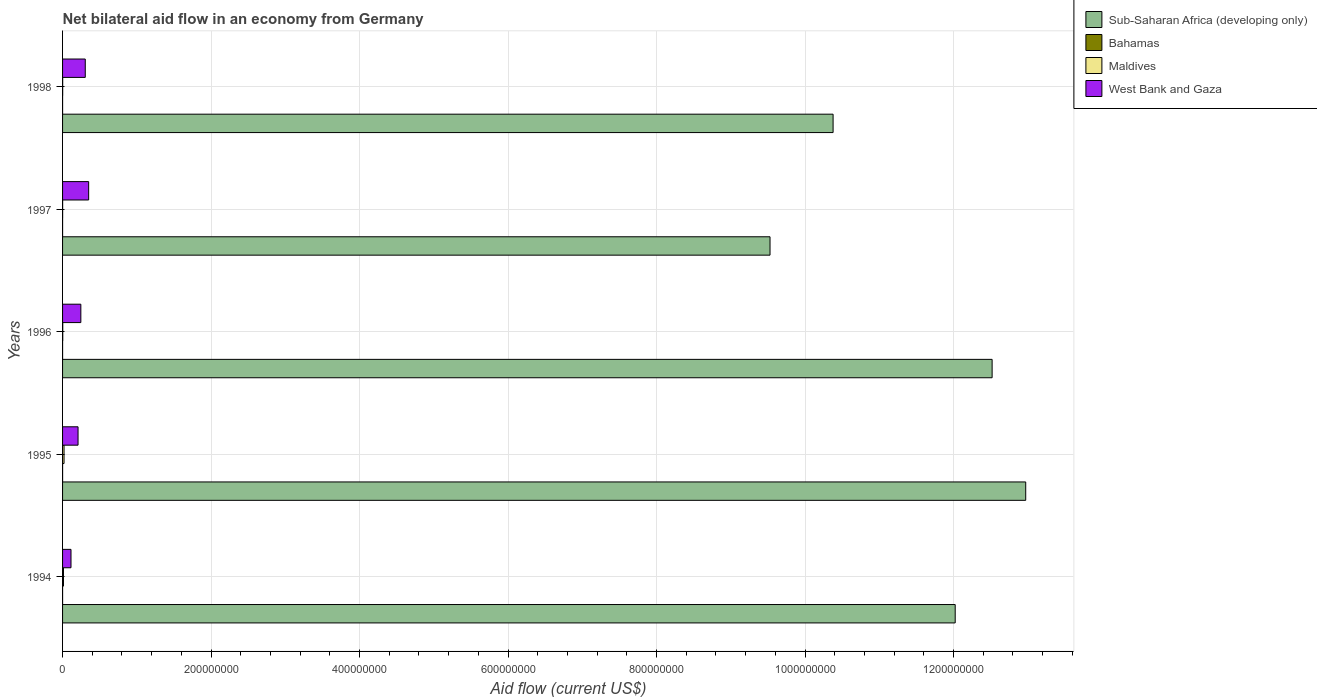How many different coloured bars are there?
Make the answer very short. 4. How many groups of bars are there?
Offer a very short reply. 5. Are the number of bars per tick equal to the number of legend labels?
Provide a succinct answer. Yes. Are the number of bars on each tick of the Y-axis equal?
Make the answer very short. Yes. How many bars are there on the 2nd tick from the top?
Your response must be concise. 4. In how many cases, is the number of bars for a given year not equal to the number of legend labels?
Ensure brevity in your answer.  0. What is the net bilateral aid flow in Bahamas in 1996?
Keep it short and to the point. 2.00e+04. Across all years, what is the maximum net bilateral aid flow in Maldives?
Provide a short and direct response. 1.99e+06. Across all years, what is the minimum net bilateral aid flow in Sub-Saharan Africa (developing only)?
Ensure brevity in your answer.  9.53e+08. In which year was the net bilateral aid flow in West Bank and Gaza maximum?
Your answer should be compact. 1997. In which year was the net bilateral aid flow in Maldives minimum?
Offer a terse response. 1997. What is the total net bilateral aid flow in Maldives in the graph?
Provide a short and direct response. 3.70e+06. What is the difference between the net bilateral aid flow in West Bank and Gaza in 1994 and that in 1996?
Give a very brief answer. -1.32e+07. What is the difference between the net bilateral aid flow in Bahamas in 1994 and the net bilateral aid flow in West Bank and Gaza in 1997?
Your answer should be compact. -3.51e+07. What is the average net bilateral aid flow in Sub-Saharan Africa (developing only) per year?
Provide a succinct answer. 1.15e+09. In the year 1994, what is the difference between the net bilateral aid flow in Bahamas and net bilateral aid flow in West Bank and Gaza?
Provide a short and direct response. -1.14e+07. What is the ratio of the net bilateral aid flow in West Bank and Gaza in 1996 to that in 1998?
Make the answer very short. 0.8. Is the difference between the net bilateral aid flow in Bahamas in 1997 and 1998 greater than the difference between the net bilateral aid flow in West Bank and Gaza in 1997 and 1998?
Provide a succinct answer. No. What is the difference between the highest and the lowest net bilateral aid flow in Sub-Saharan Africa (developing only)?
Keep it short and to the point. 3.44e+08. What does the 2nd bar from the top in 1998 represents?
Ensure brevity in your answer.  Maldives. What does the 2nd bar from the bottom in 1997 represents?
Keep it short and to the point. Bahamas. Is it the case that in every year, the sum of the net bilateral aid flow in Bahamas and net bilateral aid flow in Maldives is greater than the net bilateral aid flow in West Bank and Gaza?
Ensure brevity in your answer.  No. How many bars are there?
Your answer should be compact. 20. Are all the bars in the graph horizontal?
Provide a succinct answer. Yes. What is the difference between two consecutive major ticks on the X-axis?
Offer a very short reply. 2.00e+08. Where does the legend appear in the graph?
Provide a short and direct response. Top right. How many legend labels are there?
Make the answer very short. 4. How are the legend labels stacked?
Give a very brief answer. Vertical. What is the title of the graph?
Keep it short and to the point. Net bilateral aid flow in an economy from Germany. What is the Aid flow (current US$) of Sub-Saharan Africa (developing only) in 1994?
Give a very brief answer. 1.20e+09. What is the Aid flow (current US$) in Maldives in 1994?
Provide a short and direct response. 1.24e+06. What is the Aid flow (current US$) in West Bank and Gaza in 1994?
Make the answer very short. 1.14e+07. What is the Aid flow (current US$) of Sub-Saharan Africa (developing only) in 1995?
Keep it short and to the point. 1.30e+09. What is the Aid flow (current US$) of Maldives in 1995?
Your answer should be compact. 1.99e+06. What is the Aid flow (current US$) in West Bank and Gaza in 1995?
Your answer should be compact. 2.09e+07. What is the Aid flow (current US$) in Sub-Saharan Africa (developing only) in 1996?
Offer a terse response. 1.25e+09. What is the Aid flow (current US$) of West Bank and Gaza in 1996?
Keep it short and to the point. 2.46e+07. What is the Aid flow (current US$) of Sub-Saharan Africa (developing only) in 1997?
Ensure brevity in your answer.  9.53e+08. What is the Aid flow (current US$) in Maldives in 1997?
Offer a very short reply. 7.00e+04. What is the Aid flow (current US$) in West Bank and Gaza in 1997?
Your answer should be very brief. 3.51e+07. What is the Aid flow (current US$) in Sub-Saharan Africa (developing only) in 1998?
Give a very brief answer. 1.04e+09. What is the Aid flow (current US$) in West Bank and Gaza in 1998?
Give a very brief answer. 3.06e+07. Across all years, what is the maximum Aid flow (current US$) in Sub-Saharan Africa (developing only)?
Give a very brief answer. 1.30e+09. Across all years, what is the maximum Aid flow (current US$) of Bahamas?
Provide a short and direct response. 3.00e+04. Across all years, what is the maximum Aid flow (current US$) of Maldives?
Your response must be concise. 1.99e+06. Across all years, what is the maximum Aid flow (current US$) of West Bank and Gaza?
Keep it short and to the point. 3.51e+07. Across all years, what is the minimum Aid flow (current US$) in Sub-Saharan Africa (developing only)?
Ensure brevity in your answer.  9.53e+08. Across all years, what is the minimum Aid flow (current US$) of Bahamas?
Your response must be concise. 10000. Across all years, what is the minimum Aid flow (current US$) of West Bank and Gaza?
Provide a short and direct response. 1.14e+07. What is the total Aid flow (current US$) of Sub-Saharan Africa (developing only) in the graph?
Your response must be concise. 5.74e+09. What is the total Aid flow (current US$) in Maldives in the graph?
Keep it short and to the point. 3.70e+06. What is the total Aid flow (current US$) in West Bank and Gaza in the graph?
Provide a succinct answer. 1.23e+08. What is the difference between the Aid flow (current US$) in Sub-Saharan Africa (developing only) in 1994 and that in 1995?
Provide a succinct answer. -9.50e+07. What is the difference between the Aid flow (current US$) of Maldives in 1994 and that in 1995?
Keep it short and to the point. -7.50e+05. What is the difference between the Aid flow (current US$) in West Bank and Gaza in 1994 and that in 1995?
Offer a very short reply. -9.50e+06. What is the difference between the Aid flow (current US$) of Sub-Saharan Africa (developing only) in 1994 and that in 1996?
Give a very brief answer. -4.97e+07. What is the difference between the Aid flow (current US$) in Maldives in 1994 and that in 1996?
Make the answer very short. 9.90e+05. What is the difference between the Aid flow (current US$) in West Bank and Gaza in 1994 and that in 1996?
Your response must be concise. -1.32e+07. What is the difference between the Aid flow (current US$) of Sub-Saharan Africa (developing only) in 1994 and that in 1997?
Offer a very short reply. 2.49e+08. What is the difference between the Aid flow (current US$) of Maldives in 1994 and that in 1997?
Give a very brief answer. 1.17e+06. What is the difference between the Aid flow (current US$) in West Bank and Gaza in 1994 and that in 1997?
Provide a succinct answer. -2.38e+07. What is the difference between the Aid flow (current US$) of Sub-Saharan Africa (developing only) in 1994 and that in 1998?
Your answer should be very brief. 1.64e+08. What is the difference between the Aid flow (current US$) in Maldives in 1994 and that in 1998?
Give a very brief answer. 1.09e+06. What is the difference between the Aid flow (current US$) of West Bank and Gaza in 1994 and that in 1998?
Keep it short and to the point. -1.92e+07. What is the difference between the Aid flow (current US$) in Sub-Saharan Africa (developing only) in 1995 and that in 1996?
Offer a very short reply. 4.52e+07. What is the difference between the Aid flow (current US$) in Bahamas in 1995 and that in 1996?
Provide a succinct answer. 10000. What is the difference between the Aid flow (current US$) of Maldives in 1995 and that in 1996?
Your answer should be compact. 1.74e+06. What is the difference between the Aid flow (current US$) of West Bank and Gaza in 1995 and that in 1996?
Give a very brief answer. -3.75e+06. What is the difference between the Aid flow (current US$) of Sub-Saharan Africa (developing only) in 1995 and that in 1997?
Your answer should be very brief. 3.44e+08. What is the difference between the Aid flow (current US$) in Bahamas in 1995 and that in 1997?
Your response must be concise. 2.00e+04. What is the difference between the Aid flow (current US$) in Maldives in 1995 and that in 1997?
Offer a very short reply. 1.92e+06. What is the difference between the Aid flow (current US$) in West Bank and Gaza in 1995 and that in 1997?
Your response must be concise. -1.43e+07. What is the difference between the Aid flow (current US$) in Sub-Saharan Africa (developing only) in 1995 and that in 1998?
Provide a succinct answer. 2.59e+08. What is the difference between the Aid flow (current US$) in Bahamas in 1995 and that in 1998?
Give a very brief answer. 2.00e+04. What is the difference between the Aid flow (current US$) of Maldives in 1995 and that in 1998?
Your answer should be very brief. 1.84e+06. What is the difference between the Aid flow (current US$) of West Bank and Gaza in 1995 and that in 1998?
Provide a short and direct response. -9.72e+06. What is the difference between the Aid flow (current US$) of Sub-Saharan Africa (developing only) in 1996 and that in 1997?
Offer a terse response. 2.99e+08. What is the difference between the Aid flow (current US$) in Maldives in 1996 and that in 1997?
Keep it short and to the point. 1.80e+05. What is the difference between the Aid flow (current US$) in West Bank and Gaza in 1996 and that in 1997?
Keep it short and to the point. -1.05e+07. What is the difference between the Aid flow (current US$) in Sub-Saharan Africa (developing only) in 1996 and that in 1998?
Offer a terse response. 2.14e+08. What is the difference between the Aid flow (current US$) of West Bank and Gaza in 1996 and that in 1998?
Give a very brief answer. -5.97e+06. What is the difference between the Aid flow (current US$) of Sub-Saharan Africa (developing only) in 1997 and that in 1998?
Offer a very short reply. -8.49e+07. What is the difference between the Aid flow (current US$) in Bahamas in 1997 and that in 1998?
Ensure brevity in your answer.  0. What is the difference between the Aid flow (current US$) of West Bank and Gaza in 1997 and that in 1998?
Your answer should be compact. 4.56e+06. What is the difference between the Aid flow (current US$) of Sub-Saharan Africa (developing only) in 1994 and the Aid flow (current US$) of Bahamas in 1995?
Make the answer very short. 1.20e+09. What is the difference between the Aid flow (current US$) in Sub-Saharan Africa (developing only) in 1994 and the Aid flow (current US$) in Maldives in 1995?
Make the answer very short. 1.20e+09. What is the difference between the Aid flow (current US$) in Sub-Saharan Africa (developing only) in 1994 and the Aid flow (current US$) in West Bank and Gaza in 1995?
Your answer should be very brief. 1.18e+09. What is the difference between the Aid flow (current US$) in Bahamas in 1994 and the Aid flow (current US$) in Maldives in 1995?
Your answer should be very brief. -1.98e+06. What is the difference between the Aid flow (current US$) of Bahamas in 1994 and the Aid flow (current US$) of West Bank and Gaza in 1995?
Provide a succinct answer. -2.08e+07. What is the difference between the Aid flow (current US$) in Maldives in 1994 and the Aid flow (current US$) in West Bank and Gaza in 1995?
Your answer should be very brief. -1.96e+07. What is the difference between the Aid flow (current US$) of Sub-Saharan Africa (developing only) in 1994 and the Aid flow (current US$) of Bahamas in 1996?
Provide a succinct answer. 1.20e+09. What is the difference between the Aid flow (current US$) of Sub-Saharan Africa (developing only) in 1994 and the Aid flow (current US$) of Maldives in 1996?
Give a very brief answer. 1.20e+09. What is the difference between the Aid flow (current US$) of Sub-Saharan Africa (developing only) in 1994 and the Aid flow (current US$) of West Bank and Gaza in 1996?
Give a very brief answer. 1.18e+09. What is the difference between the Aid flow (current US$) in Bahamas in 1994 and the Aid flow (current US$) in Maldives in 1996?
Give a very brief answer. -2.40e+05. What is the difference between the Aid flow (current US$) of Bahamas in 1994 and the Aid flow (current US$) of West Bank and Gaza in 1996?
Ensure brevity in your answer.  -2.46e+07. What is the difference between the Aid flow (current US$) in Maldives in 1994 and the Aid flow (current US$) in West Bank and Gaza in 1996?
Offer a very short reply. -2.34e+07. What is the difference between the Aid flow (current US$) in Sub-Saharan Africa (developing only) in 1994 and the Aid flow (current US$) in Bahamas in 1997?
Your answer should be compact. 1.20e+09. What is the difference between the Aid flow (current US$) of Sub-Saharan Africa (developing only) in 1994 and the Aid flow (current US$) of Maldives in 1997?
Your answer should be very brief. 1.20e+09. What is the difference between the Aid flow (current US$) of Sub-Saharan Africa (developing only) in 1994 and the Aid flow (current US$) of West Bank and Gaza in 1997?
Ensure brevity in your answer.  1.17e+09. What is the difference between the Aid flow (current US$) of Bahamas in 1994 and the Aid flow (current US$) of Maldives in 1997?
Ensure brevity in your answer.  -6.00e+04. What is the difference between the Aid flow (current US$) of Bahamas in 1994 and the Aid flow (current US$) of West Bank and Gaza in 1997?
Your answer should be very brief. -3.51e+07. What is the difference between the Aid flow (current US$) of Maldives in 1994 and the Aid flow (current US$) of West Bank and Gaza in 1997?
Your response must be concise. -3.39e+07. What is the difference between the Aid flow (current US$) in Sub-Saharan Africa (developing only) in 1994 and the Aid flow (current US$) in Bahamas in 1998?
Give a very brief answer. 1.20e+09. What is the difference between the Aid flow (current US$) in Sub-Saharan Africa (developing only) in 1994 and the Aid flow (current US$) in Maldives in 1998?
Provide a short and direct response. 1.20e+09. What is the difference between the Aid flow (current US$) of Sub-Saharan Africa (developing only) in 1994 and the Aid flow (current US$) of West Bank and Gaza in 1998?
Your response must be concise. 1.17e+09. What is the difference between the Aid flow (current US$) in Bahamas in 1994 and the Aid flow (current US$) in Maldives in 1998?
Give a very brief answer. -1.40e+05. What is the difference between the Aid flow (current US$) of Bahamas in 1994 and the Aid flow (current US$) of West Bank and Gaza in 1998?
Provide a succinct answer. -3.06e+07. What is the difference between the Aid flow (current US$) in Maldives in 1994 and the Aid flow (current US$) in West Bank and Gaza in 1998?
Ensure brevity in your answer.  -2.93e+07. What is the difference between the Aid flow (current US$) in Sub-Saharan Africa (developing only) in 1995 and the Aid flow (current US$) in Bahamas in 1996?
Ensure brevity in your answer.  1.30e+09. What is the difference between the Aid flow (current US$) in Sub-Saharan Africa (developing only) in 1995 and the Aid flow (current US$) in Maldives in 1996?
Provide a succinct answer. 1.30e+09. What is the difference between the Aid flow (current US$) of Sub-Saharan Africa (developing only) in 1995 and the Aid flow (current US$) of West Bank and Gaza in 1996?
Your answer should be compact. 1.27e+09. What is the difference between the Aid flow (current US$) of Bahamas in 1995 and the Aid flow (current US$) of Maldives in 1996?
Make the answer very short. -2.20e+05. What is the difference between the Aid flow (current US$) in Bahamas in 1995 and the Aid flow (current US$) in West Bank and Gaza in 1996?
Your answer should be compact. -2.46e+07. What is the difference between the Aid flow (current US$) of Maldives in 1995 and the Aid flow (current US$) of West Bank and Gaza in 1996?
Provide a short and direct response. -2.26e+07. What is the difference between the Aid flow (current US$) in Sub-Saharan Africa (developing only) in 1995 and the Aid flow (current US$) in Bahamas in 1997?
Provide a succinct answer. 1.30e+09. What is the difference between the Aid flow (current US$) of Sub-Saharan Africa (developing only) in 1995 and the Aid flow (current US$) of Maldives in 1997?
Provide a succinct answer. 1.30e+09. What is the difference between the Aid flow (current US$) of Sub-Saharan Africa (developing only) in 1995 and the Aid flow (current US$) of West Bank and Gaza in 1997?
Your answer should be compact. 1.26e+09. What is the difference between the Aid flow (current US$) of Bahamas in 1995 and the Aid flow (current US$) of West Bank and Gaza in 1997?
Give a very brief answer. -3.51e+07. What is the difference between the Aid flow (current US$) of Maldives in 1995 and the Aid flow (current US$) of West Bank and Gaza in 1997?
Offer a terse response. -3.32e+07. What is the difference between the Aid flow (current US$) of Sub-Saharan Africa (developing only) in 1995 and the Aid flow (current US$) of Bahamas in 1998?
Make the answer very short. 1.30e+09. What is the difference between the Aid flow (current US$) in Sub-Saharan Africa (developing only) in 1995 and the Aid flow (current US$) in Maldives in 1998?
Provide a short and direct response. 1.30e+09. What is the difference between the Aid flow (current US$) in Sub-Saharan Africa (developing only) in 1995 and the Aid flow (current US$) in West Bank and Gaza in 1998?
Offer a very short reply. 1.27e+09. What is the difference between the Aid flow (current US$) in Bahamas in 1995 and the Aid flow (current US$) in Maldives in 1998?
Give a very brief answer. -1.20e+05. What is the difference between the Aid flow (current US$) in Bahamas in 1995 and the Aid flow (current US$) in West Bank and Gaza in 1998?
Your answer should be compact. -3.06e+07. What is the difference between the Aid flow (current US$) of Maldives in 1995 and the Aid flow (current US$) of West Bank and Gaza in 1998?
Your answer should be compact. -2.86e+07. What is the difference between the Aid flow (current US$) of Sub-Saharan Africa (developing only) in 1996 and the Aid flow (current US$) of Bahamas in 1997?
Make the answer very short. 1.25e+09. What is the difference between the Aid flow (current US$) in Sub-Saharan Africa (developing only) in 1996 and the Aid flow (current US$) in Maldives in 1997?
Provide a short and direct response. 1.25e+09. What is the difference between the Aid flow (current US$) in Sub-Saharan Africa (developing only) in 1996 and the Aid flow (current US$) in West Bank and Gaza in 1997?
Ensure brevity in your answer.  1.22e+09. What is the difference between the Aid flow (current US$) in Bahamas in 1996 and the Aid flow (current US$) in Maldives in 1997?
Your answer should be compact. -5.00e+04. What is the difference between the Aid flow (current US$) of Bahamas in 1996 and the Aid flow (current US$) of West Bank and Gaza in 1997?
Ensure brevity in your answer.  -3.51e+07. What is the difference between the Aid flow (current US$) of Maldives in 1996 and the Aid flow (current US$) of West Bank and Gaza in 1997?
Your answer should be very brief. -3.49e+07. What is the difference between the Aid flow (current US$) of Sub-Saharan Africa (developing only) in 1996 and the Aid flow (current US$) of Bahamas in 1998?
Keep it short and to the point. 1.25e+09. What is the difference between the Aid flow (current US$) in Sub-Saharan Africa (developing only) in 1996 and the Aid flow (current US$) in Maldives in 1998?
Provide a succinct answer. 1.25e+09. What is the difference between the Aid flow (current US$) in Sub-Saharan Africa (developing only) in 1996 and the Aid flow (current US$) in West Bank and Gaza in 1998?
Your answer should be very brief. 1.22e+09. What is the difference between the Aid flow (current US$) in Bahamas in 1996 and the Aid flow (current US$) in West Bank and Gaza in 1998?
Offer a very short reply. -3.06e+07. What is the difference between the Aid flow (current US$) in Maldives in 1996 and the Aid flow (current US$) in West Bank and Gaza in 1998?
Keep it short and to the point. -3.03e+07. What is the difference between the Aid flow (current US$) in Sub-Saharan Africa (developing only) in 1997 and the Aid flow (current US$) in Bahamas in 1998?
Make the answer very short. 9.53e+08. What is the difference between the Aid flow (current US$) in Sub-Saharan Africa (developing only) in 1997 and the Aid flow (current US$) in Maldives in 1998?
Make the answer very short. 9.53e+08. What is the difference between the Aid flow (current US$) in Sub-Saharan Africa (developing only) in 1997 and the Aid flow (current US$) in West Bank and Gaza in 1998?
Offer a very short reply. 9.22e+08. What is the difference between the Aid flow (current US$) in Bahamas in 1997 and the Aid flow (current US$) in West Bank and Gaza in 1998?
Give a very brief answer. -3.06e+07. What is the difference between the Aid flow (current US$) of Maldives in 1997 and the Aid flow (current US$) of West Bank and Gaza in 1998?
Offer a very short reply. -3.05e+07. What is the average Aid flow (current US$) in Sub-Saharan Africa (developing only) per year?
Offer a terse response. 1.15e+09. What is the average Aid flow (current US$) in Bahamas per year?
Keep it short and to the point. 1.60e+04. What is the average Aid flow (current US$) in Maldives per year?
Offer a very short reply. 7.40e+05. What is the average Aid flow (current US$) of West Bank and Gaza per year?
Ensure brevity in your answer.  2.45e+07. In the year 1994, what is the difference between the Aid flow (current US$) in Sub-Saharan Africa (developing only) and Aid flow (current US$) in Bahamas?
Provide a succinct answer. 1.20e+09. In the year 1994, what is the difference between the Aid flow (current US$) of Sub-Saharan Africa (developing only) and Aid flow (current US$) of Maldives?
Give a very brief answer. 1.20e+09. In the year 1994, what is the difference between the Aid flow (current US$) in Sub-Saharan Africa (developing only) and Aid flow (current US$) in West Bank and Gaza?
Ensure brevity in your answer.  1.19e+09. In the year 1994, what is the difference between the Aid flow (current US$) of Bahamas and Aid flow (current US$) of Maldives?
Offer a terse response. -1.23e+06. In the year 1994, what is the difference between the Aid flow (current US$) in Bahamas and Aid flow (current US$) in West Bank and Gaza?
Your answer should be compact. -1.14e+07. In the year 1994, what is the difference between the Aid flow (current US$) in Maldives and Aid flow (current US$) in West Bank and Gaza?
Your response must be concise. -1.01e+07. In the year 1995, what is the difference between the Aid flow (current US$) in Sub-Saharan Africa (developing only) and Aid flow (current US$) in Bahamas?
Your answer should be very brief. 1.30e+09. In the year 1995, what is the difference between the Aid flow (current US$) in Sub-Saharan Africa (developing only) and Aid flow (current US$) in Maldives?
Ensure brevity in your answer.  1.30e+09. In the year 1995, what is the difference between the Aid flow (current US$) in Sub-Saharan Africa (developing only) and Aid flow (current US$) in West Bank and Gaza?
Offer a terse response. 1.28e+09. In the year 1995, what is the difference between the Aid flow (current US$) in Bahamas and Aid flow (current US$) in Maldives?
Give a very brief answer. -1.96e+06. In the year 1995, what is the difference between the Aid flow (current US$) of Bahamas and Aid flow (current US$) of West Bank and Gaza?
Your answer should be compact. -2.08e+07. In the year 1995, what is the difference between the Aid flow (current US$) in Maldives and Aid flow (current US$) in West Bank and Gaza?
Make the answer very short. -1.89e+07. In the year 1996, what is the difference between the Aid flow (current US$) of Sub-Saharan Africa (developing only) and Aid flow (current US$) of Bahamas?
Ensure brevity in your answer.  1.25e+09. In the year 1996, what is the difference between the Aid flow (current US$) in Sub-Saharan Africa (developing only) and Aid flow (current US$) in Maldives?
Make the answer very short. 1.25e+09. In the year 1996, what is the difference between the Aid flow (current US$) of Sub-Saharan Africa (developing only) and Aid flow (current US$) of West Bank and Gaza?
Provide a short and direct response. 1.23e+09. In the year 1996, what is the difference between the Aid flow (current US$) of Bahamas and Aid flow (current US$) of Maldives?
Give a very brief answer. -2.30e+05. In the year 1996, what is the difference between the Aid flow (current US$) of Bahamas and Aid flow (current US$) of West Bank and Gaza?
Make the answer very short. -2.46e+07. In the year 1996, what is the difference between the Aid flow (current US$) in Maldives and Aid flow (current US$) in West Bank and Gaza?
Provide a succinct answer. -2.44e+07. In the year 1997, what is the difference between the Aid flow (current US$) of Sub-Saharan Africa (developing only) and Aid flow (current US$) of Bahamas?
Your answer should be very brief. 9.53e+08. In the year 1997, what is the difference between the Aid flow (current US$) in Sub-Saharan Africa (developing only) and Aid flow (current US$) in Maldives?
Keep it short and to the point. 9.53e+08. In the year 1997, what is the difference between the Aid flow (current US$) in Sub-Saharan Africa (developing only) and Aid flow (current US$) in West Bank and Gaza?
Offer a terse response. 9.18e+08. In the year 1997, what is the difference between the Aid flow (current US$) in Bahamas and Aid flow (current US$) in Maldives?
Offer a terse response. -6.00e+04. In the year 1997, what is the difference between the Aid flow (current US$) in Bahamas and Aid flow (current US$) in West Bank and Gaza?
Your answer should be compact. -3.51e+07. In the year 1997, what is the difference between the Aid flow (current US$) of Maldives and Aid flow (current US$) of West Bank and Gaza?
Offer a terse response. -3.51e+07. In the year 1998, what is the difference between the Aid flow (current US$) of Sub-Saharan Africa (developing only) and Aid flow (current US$) of Bahamas?
Keep it short and to the point. 1.04e+09. In the year 1998, what is the difference between the Aid flow (current US$) in Sub-Saharan Africa (developing only) and Aid flow (current US$) in Maldives?
Your response must be concise. 1.04e+09. In the year 1998, what is the difference between the Aid flow (current US$) in Sub-Saharan Africa (developing only) and Aid flow (current US$) in West Bank and Gaza?
Keep it short and to the point. 1.01e+09. In the year 1998, what is the difference between the Aid flow (current US$) in Bahamas and Aid flow (current US$) in West Bank and Gaza?
Offer a very short reply. -3.06e+07. In the year 1998, what is the difference between the Aid flow (current US$) of Maldives and Aid flow (current US$) of West Bank and Gaza?
Your answer should be very brief. -3.04e+07. What is the ratio of the Aid flow (current US$) of Sub-Saharan Africa (developing only) in 1994 to that in 1995?
Keep it short and to the point. 0.93. What is the ratio of the Aid flow (current US$) in Maldives in 1994 to that in 1995?
Ensure brevity in your answer.  0.62. What is the ratio of the Aid flow (current US$) of West Bank and Gaza in 1994 to that in 1995?
Ensure brevity in your answer.  0.54. What is the ratio of the Aid flow (current US$) in Sub-Saharan Africa (developing only) in 1994 to that in 1996?
Give a very brief answer. 0.96. What is the ratio of the Aid flow (current US$) of Bahamas in 1994 to that in 1996?
Offer a very short reply. 0.5. What is the ratio of the Aid flow (current US$) of Maldives in 1994 to that in 1996?
Make the answer very short. 4.96. What is the ratio of the Aid flow (current US$) in West Bank and Gaza in 1994 to that in 1996?
Your response must be concise. 0.46. What is the ratio of the Aid flow (current US$) of Sub-Saharan Africa (developing only) in 1994 to that in 1997?
Your answer should be compact. 1.26. What is the ratio of the Aid flow (current US$) of Bahamas in 1994 to that in 1997?
Make the answer very short. 1. What is the ratio of the Aid flow (current US$) of Maldives in 1994 to that in 1997?
Keep it short and to the point. 17.71. What is the ratio of the Aid flow (current US$) in West Bank and Gaza in 1994 to that in 1997?
Provide a short and direct response. 0.32. What is the ratio of the Aid flow (current US$) in Sub-Saharan Africa (developing only) in 1994 to that in 1998?
Keep it short and to the point. 1.16. What is the ratio of the Aid flow (current US$) in Maldives in 1994 to that in 1998?
Your answer should be very brief. 8.27. What is the ratio of the Aid flow (current US$) in West Bank and Gaza in 1994 to that in 1998?
Give a very brief answer. 0.37. What is the ratio of the Aid flow (current US$) in Sub-Saharan Africa (developing only) in 1995 to that in 1996?
Give a very brief answer. 1.04. What is the ratio of the Aid flow (current US$) of Bahamas in 1995 to that in 1996?
Your response must be concise. 1.5. What is the ratio of the Aid flow (current US$) of Maldives in 1995 to that in 1996?
Provide a short and direct response. 7.96. What is the ratio of the Aid flow (current US$) in West Bank and Gaza in 1995 to that in 1996?
Provide a short and direct response. 0.85. What is the ratio of the Aid flow (current US$) in Sub-Saharan Africa (developing only) in 1995 to that in 1997?
Give a very brief answer. 1.36. What is the ratio of the Aid flow (current US$) in Maldives in 1995 to that in 1997?
Provide a succinct answer. 28.43. What is the ratio of the Aid flow (current US$) of West Bank and Gaza in 1995 to that in 1997?
Offer a very short reply. 0.59. What is the ratio of the Aid flow (current US$) in Maldives in 1995 to that in 1998?
Your response must be concise. 13.27. What is the ratio of the Aid flow (current US$) of West Bank and Gaza in 1995 to that in 1998?
Ensure brevity in your answer.  0.68. What is the ratio of the Aid flow (current US$) of Sub-Saharan Africa (developing only) in 1996 to that in 1997?
Your response must be concise. 1.31. What is the ratio of the Aid flow (current US$) in Maldives in 1996 to that in 1997?
Provide a short and direct response. 3.57. What is the ratio of the Aid flow (current US$) of West Bank and Gaza in 1996 to that in 1997?
Ensure brevity in your answer.  0.7. What is the ratio of the Aid flow (current US$) of Sub-Saharan Africa (developing only) in 1996 to that in 1998?
Keep it short and to the point. 1.21. What is the ratio of the Aid flow (current US$) in Bahamas in 1996 to that in 1998?
Offer a very short reply. 2. What is the ratio of the Aid flow (current US$) of Maldives in 1996 to that in 1998?
Make the answer very short. 1.67. What is the ratio of the Aid flow (current US$) of West Bank and Gaza in 1996 to that in 1998?
Your answer should be very brief. 0.8. What is the ratio of the Aid flow (current US$) of Sub-Saharan Africa (developing only) in 1997 to that in 1998?
Your answer should be very brief. 0.92. What is the ratio of the Aid flow (current US$) of Maldives in 1997 to that in 1998?
Keep it short and to the point. 0.47. What is the ratio of the Aid flow (current US$) of West Bank and Gaza in 1997 to that in 1998?
Provide a succinct answer. 1.15. What is the difference between the highest and the second highest Aid flow (current US$) in Sub-Saharan Africa (developing only)?
Make the answer very short. 4.52e+07. What is the difference between the highest and the second highest Aid flow (current US$) of Maldives?
Keep it short and to the point. 7.50e+05. What is the difference between the highest and the second highest Aid flow (current US$) of West Bank and Gaza?
Ensure brevity in your answer.  4.56e+06. What is the difference between the highest and the lowest Aid flow (current US$) in Sub-Saharan Africa (developing only)?
Your response must be concise. 3.44e+08. What is the difference between the highest and the lowest Aid flow (current US$) of Bahamas?
Your response must be concise. 2.00e+04. What is the difference between the highest and the lowest Aid flow (current US$) in Maldives?
Keep it short and to the point. 1.92e+06. What is the difference between the highest and the lowest Aid flow (current US$) of West Bank and Gaza?
Your response must be concise. 2.38e+07. 